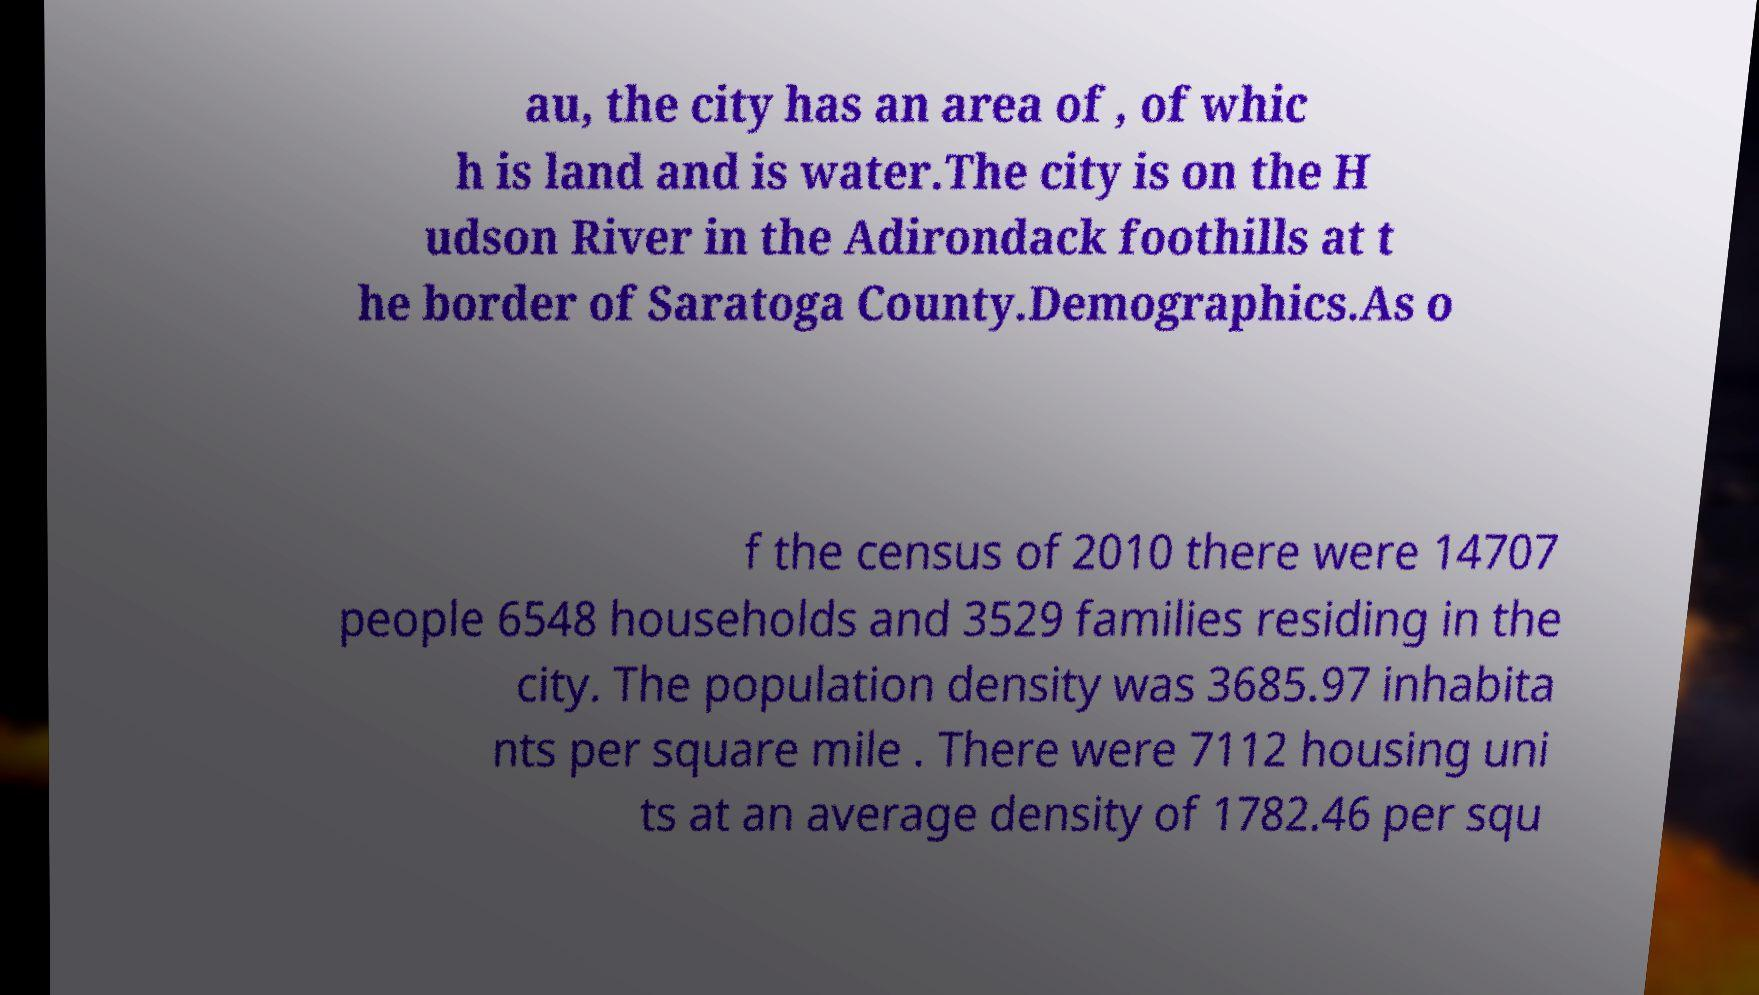What messages or text are displayed in this image? I need them in a readable, typed format. au, the city has an area of , of whic h is land and is water.The city is on the H udson River in the Adirondack foothills at t he border of Saratoga County.Demographics.As o f the census of 2010 there were 14707 people 6548 households and 3529 families residing in the city. The population density was 3685.97 inhabita nts per square mile . There were 7112 housing uni ts at an average density of 1782.46 per squ 